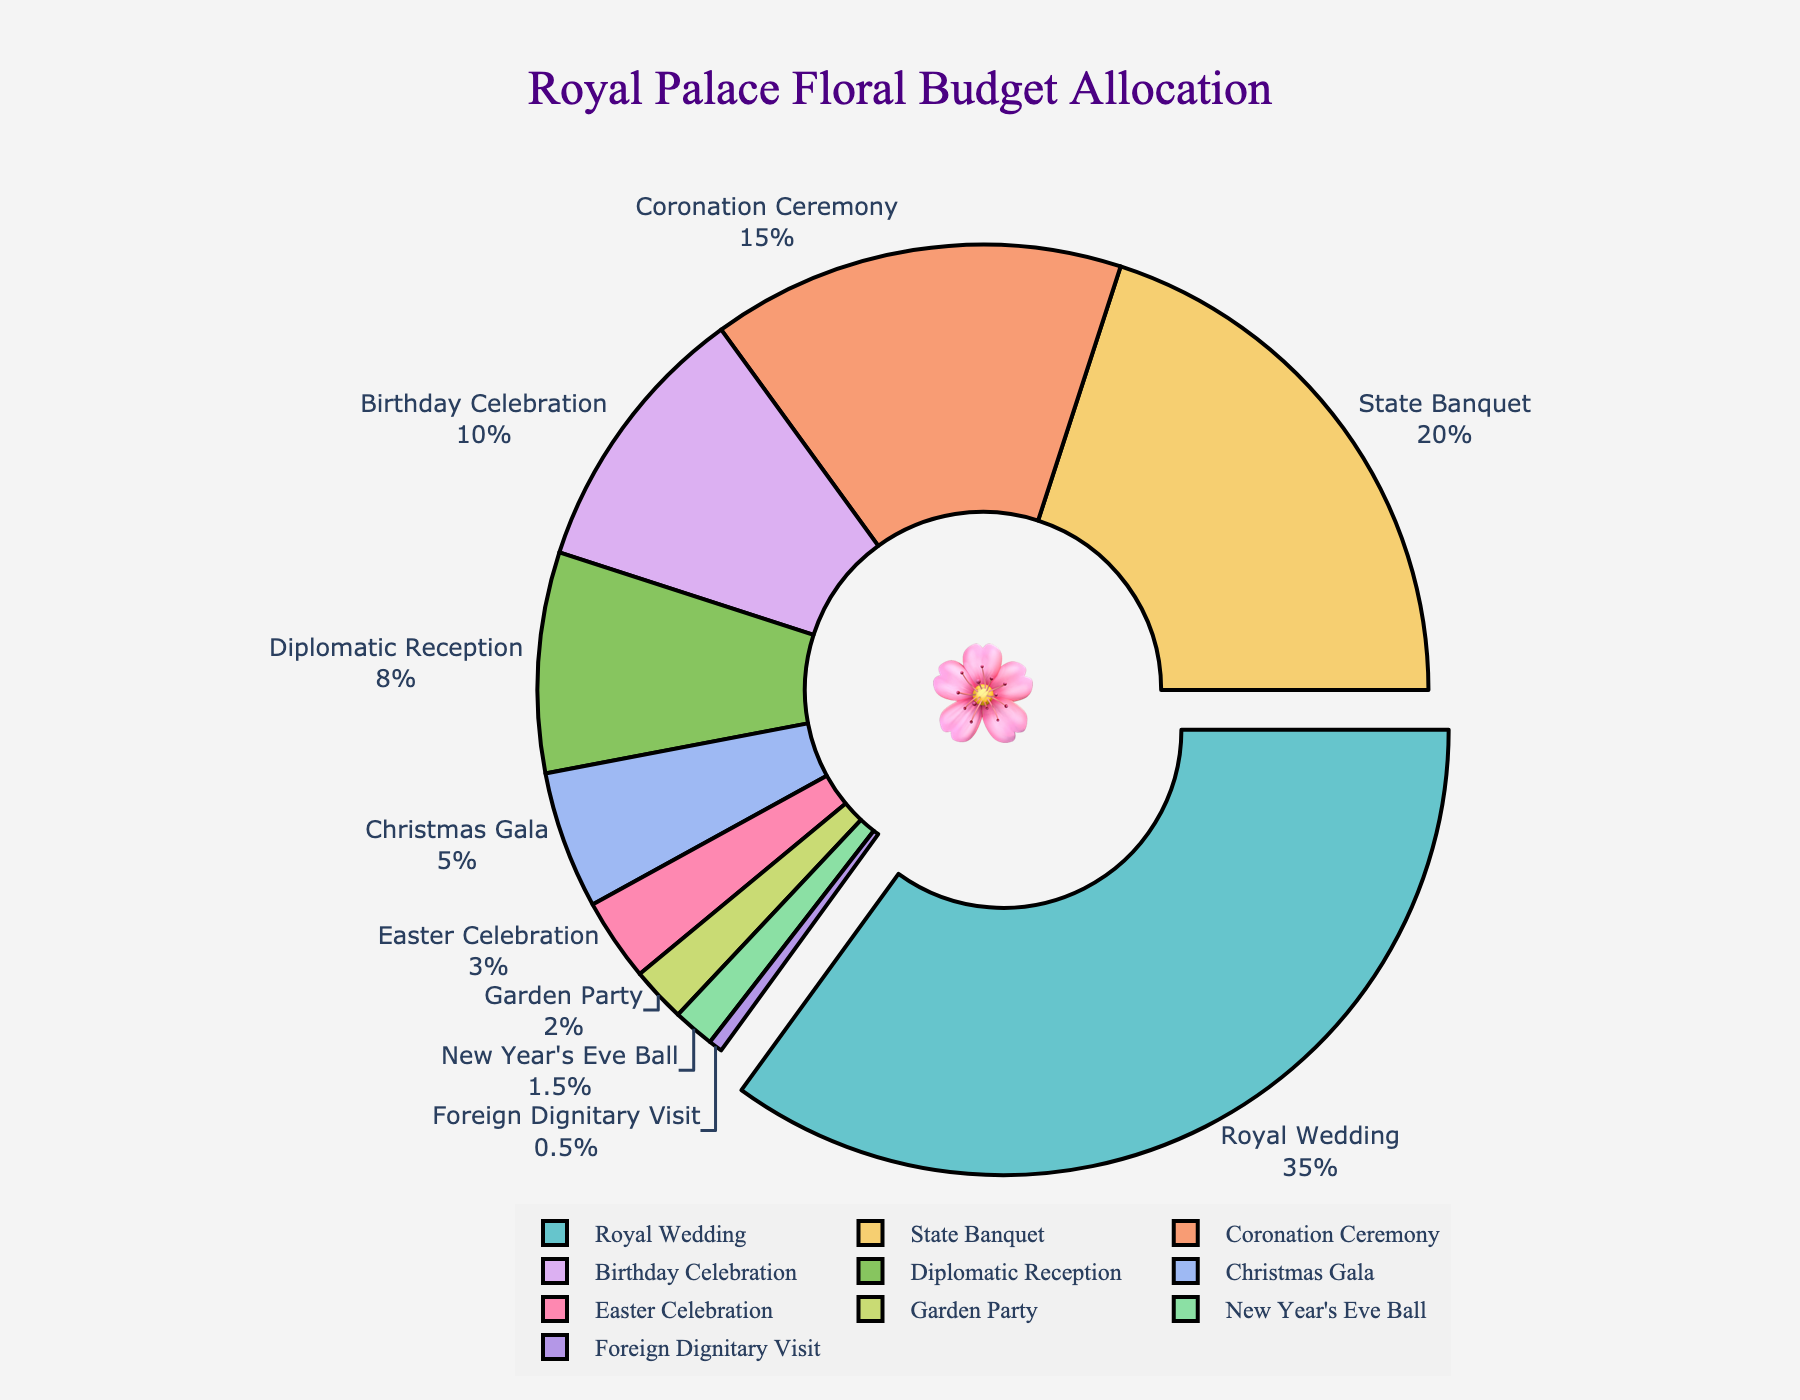what is the event with the highest floral budget allocation? By examining the pie chart, we see that the largest slice (highlighted and slightly pulled out from the center) is labeled "Royal Wedding," with a budget allocation of 35%. This indicates that the Royal Wedding has the highest floral budget allocation.
Answer: Royal Wedding What percentage of the floral budget is allocated to the Coronation Ceremony and Birthday Celebration combined? The pie chart shows that the Coronation Ceremony has a budget percentage of 15% and the Birthday Celebration has 10%. Summing these values gives 15% + 10% = 25%.
Answer: 25% Which event has a smaller budget percentage than the Christmas Gala but more than the Garden Party? According to the pie chart, the Christmas Gala has a budget percentage of 5%, and the Garden Party has 2%. The event falling in between these percentages is the Easter Celebration with 3%.
Answer: Easter Celebration Which events have a budget percentage of 10% or less? By looking at the pie chart, we identify the following events with 10% or less budget: Birthday Celebration (10%), Diplomatic Reception (8%), Christmas Gala (5%), Easter Celebration (3%), Garden Party (2%), New Year's Eve Ball (1.5%), Foreign Dignitary Visit (0.5%).
Answer: Birthday Celebration, Diplomatic Reception, Christmas Gala, Easter Celebration, Garden Party, New Year's Eve Ball, Foreign Dignitary Visit What is the budget percentage difference between the State Banquet and Diplomatic Reception? The pie chart shows that the State Banquet has a budget percentage of 20% and the Diplomatic Reception has 8%. Subtracting these values gives 20% - 8% = 12%.
Answer: 12% Which two events combined exceed the budget allocation of the State Banquet? The State Banquet has a budget allocation of 20%. From the pie chart, we look for two events whose combined allocation exceeds 20%. The Birthday Celebration has 10%, and the Diplomatic Reception has 8%, totaling 18%. This is not enough. However, the Coronation Ceremony has 15%, and Birthday Celebration has 10%, totaling 25%, which exceeds the State Banquet’s budget allocation.
Answer: Coronation Ceremony and Birthday Celebration What event has the same budget percentage as the Easter Celebration and Garden Party combined? By inspecting the pie chart, we see that the Easter Celebration has 3% and the Garden Party has 2%. Combining these values gives 3% + 2% = 5%. This matches the budget percentage of the Christmas Gala.
Answer: Christmas Gala What's the combined budget allocation for events with less than 5% each? Events with less than 5% each are Easter Celebration (3%), Garden Party (2%), New Year's Eve Ball (1.5%), and Foreign Dignitary Visit (0.5%). Summing these values gives 3% + 2% + 1.5% + 0.5% = 7%.
Answer: 7% Which event has the least floral budget allocation? The pie chart shows that the smallest slice corresponds to the Foreign Dignitary Visit with a budget percentage of 0.5%, indicating it has the least allocation.
Answer: Foreign Dignitary Visit 